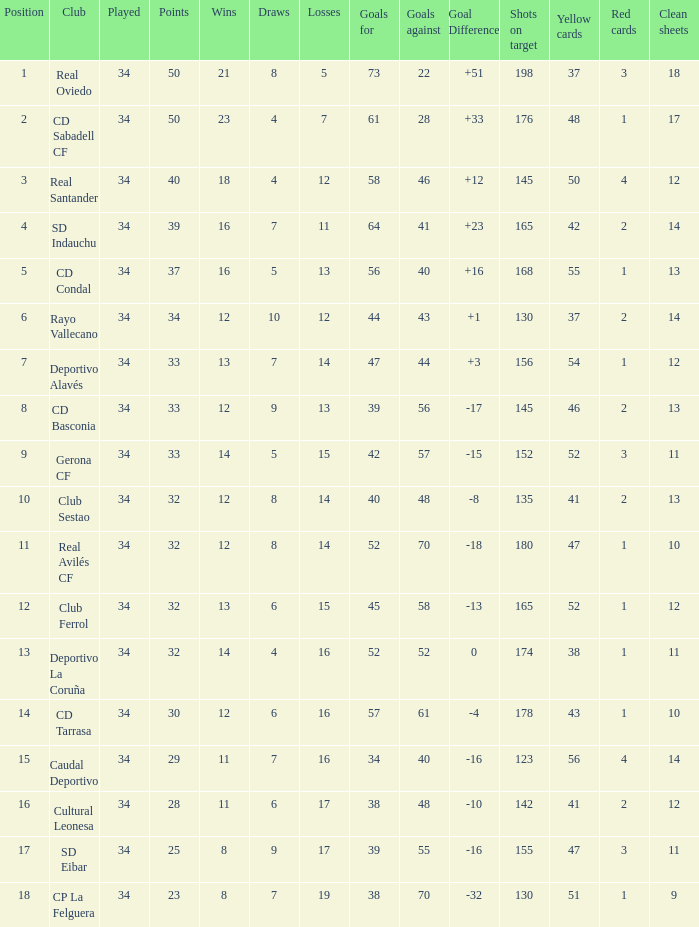Which Played has Draws smaller than 7, and Goals for smaller than 61, and Goals against smaller than 48, and a Position of 5? 34.0. 